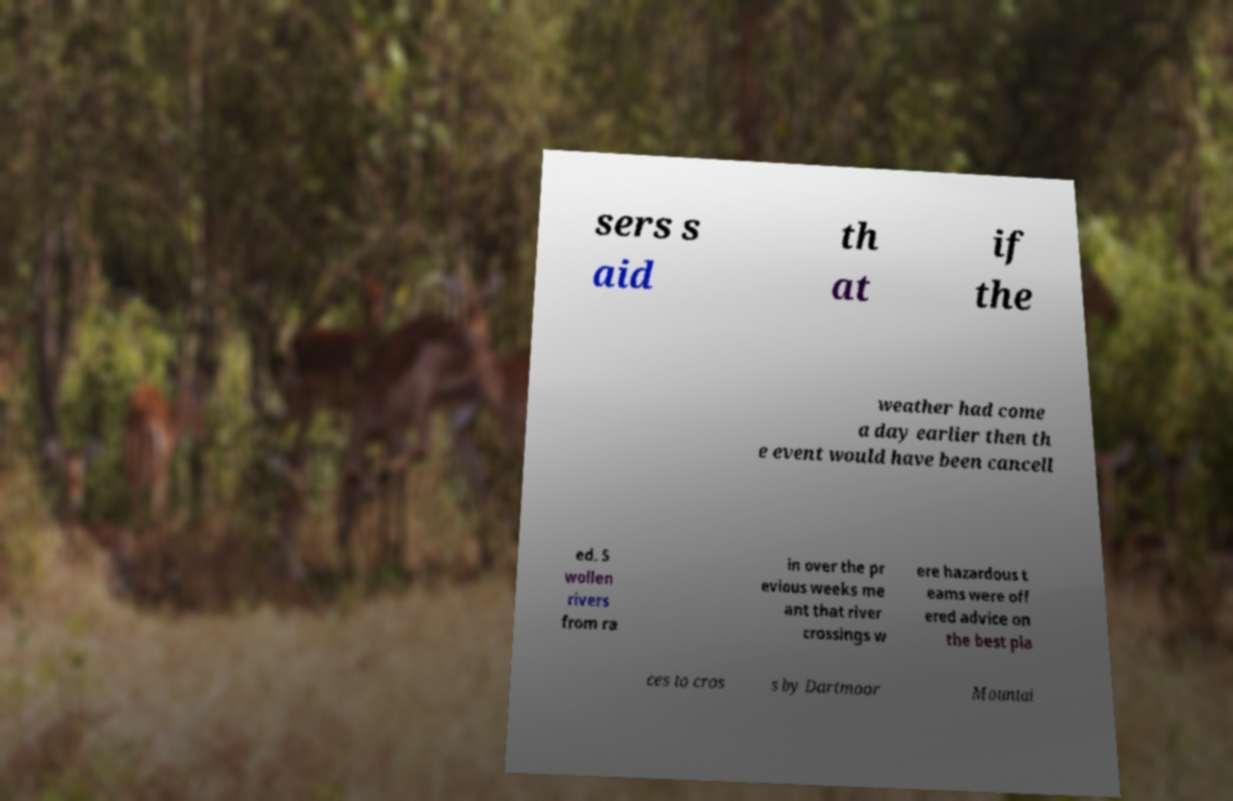Could you extract and type out the text from this image? sers s aid th at if the weather had come a day earlier then th e event would have been cancell ed. S wollen rivers from ra in over the pr evious weeks me ant that river crossings w ere hazardous t eams were off ered advice on the best pla ces to cros s by Dartmoor Mountai 